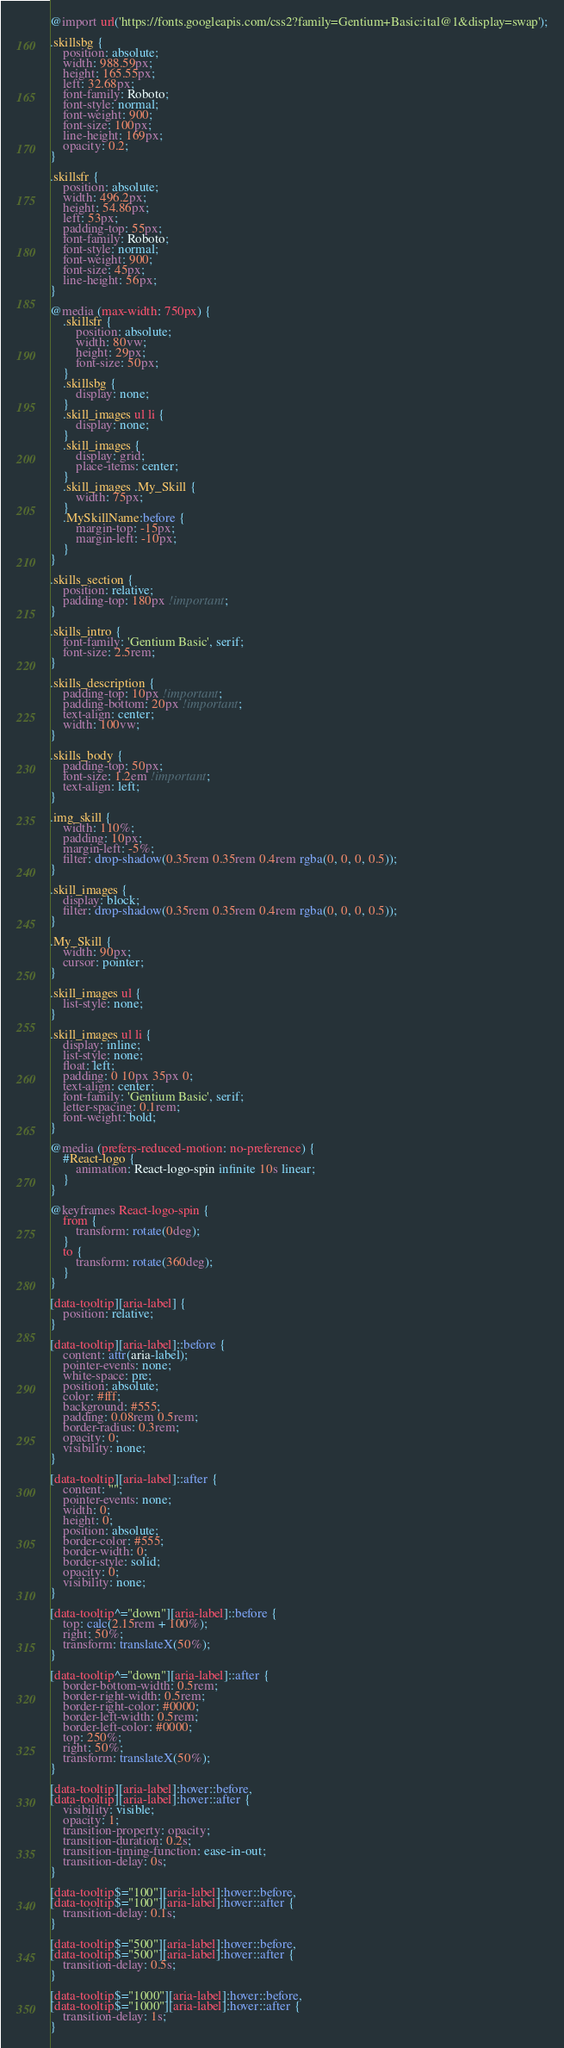<code> <loc_0><loc_0><loc_500><loc_500><_CSS_>@import url('https://fonts.googleapis.com/css2?family=Gentium+Basic:ital@1&display=swap');

.skillsbg {
    position: absolute;
    width: 988.59px;
    height: 165.55px;
    left: 32.68px;
    font-family: Roboto;
    font-style: normal;
    font-weight: 900;
    font-size: 100px;
    line-height: 169px;
    opacity: 0.2;
}

.skillsfr {
    position: absolute;
    width: 496.2px;
    height: 54.86px;
    left: 53px;
    padding-top: 55px;
    font-family: Roboto;
    font-style: normal;
    font-weight: 900;
    font-size: 45px;
    line-height: 56px;
}

@media (max-width: 750px) {
    .skillsfr {
        position: absolute;
        width: 80vw;
        height: 29px;
        font-size: 50px;
    }
    .skillsbg {
        display: none;
    }
    .skill_images ul li {
        display: none;
    }
    .skill_images {
        display: grid;
        place-items: center;
    }
    .skill_images .My_Skill {
        width: 75px;
    }
    .MySkillName:before {
        margin-top: -15px;
        margin-left: -10px;
    }
}

.skills_section {
    position: relative;
    padding-top: 180px !important;
}

.skills_intro {
    font-family: 'Gentium Basic', serif;
    font-size: 2.5rem;
}

.skills_description {
    padding-top: 10px !important;
    padding-bottom: 20px !important;
    text-align: center;
    width: 100vw;
}

.skills_body {
    padding-top: 50px;
    font-size: 1.2em !important;
    text-align: left;
}

.img_skill {
    width: 110%;
    padding: 10px;
    margin-left: -5%;
    filter: drop-shadow(0.35rem 0.35rem 0.4rem rgba(0, 0, 0, 0.5));
}

.skill_images {
    display: block;
    filter: drop-shadow(0.35rem 0.35rem 0.4rem rgba(0, 0, 0, 0.5));
}

.My_Skill {
    width: 90px;
    cursor: pointer;
}

.skill_images ul {
    list-style: none;
}

.skill_images ul li {
    display: inline;
    list-style: none;
    float: left;
    padding: 0 10px 35px 0;
    text-align: center;
    font-family: 'Gentium Basic', serif;
    letter-spacing: 0.1rem;
    font-weight: bold;
}

@media (prefers-reduced-motion: no-preference) {
    #React-logo {
        animation: React-logo-spin infinite 10s linear;
    }
}

@keyframes React-logo-spin {
    from {
        transform: rotate(0deg);
    }
    to {
        transform: rotate(360deg);
    }
}

[data-tooltip][aria-label] {
    position: relative;
}

[data-tooltip][aria-label]::before {
    content: attr(aria-label);
    pointer-events: none;
    white-space: pre;
    position: absolute;
    color: #fff;
    background: #555;
    padding: 0.08rem 0.5rem;
    border-radius: 0.3rem;
    opacity: 0;
    visibility: none;
}

[data-tooltip][aria-label]::after {
    content: "";
    pointer-events: none;
    width: 0;
    height: 0;
    position: absolute;
    border-color: #555;
    border-width: 0;
    border-style: solid;
    opacity: 0;
    visibility: none;
}

[data-tooltip^="down"][aria-label]::before {
    top: calc(2.15rem + 100%);
    right: 50%;
    transform: translateX(50%);
}

[data-tooltip^="down"][aria-label]::after {
    border-bottom-width: 0.5rem;
    border-right-width: 0.5rem;
    border-right-color: #0000;
    border-left-width: 0.5rem;
    border-left-color: #0000;
    top: 250%;
    right: 50%;
    transform: translateX(50%);
}

[data-tooltip][aria-label]:hover::before,
[data-tooltip][aria-label]:hover::after {
    visibility: visible;
    opacity: 1;
    transition-property: opacity;
    transition-duration: 0.2s;
    transition-timing-function: ease-in-out;
    transition-delay: 0s;
}

[data-tooltip$="100"][aria-label]:hover::before,
[data-tooltip$="100"][aria-label]:hover::after {
    transition-delay: 0.1s;
}

[data-tooltip$="500"][aria-label]:hover::before,
[data-tooltip$="500"][aria-label]:hover::after {
    transition-delay: 0.5s;
}

[data-tooltip$="1000"][aria-label]:hover::before,
[data-tooltip$="1000"][aria-label]:hover::after {
    transition-delay: 1s;
}</code> 